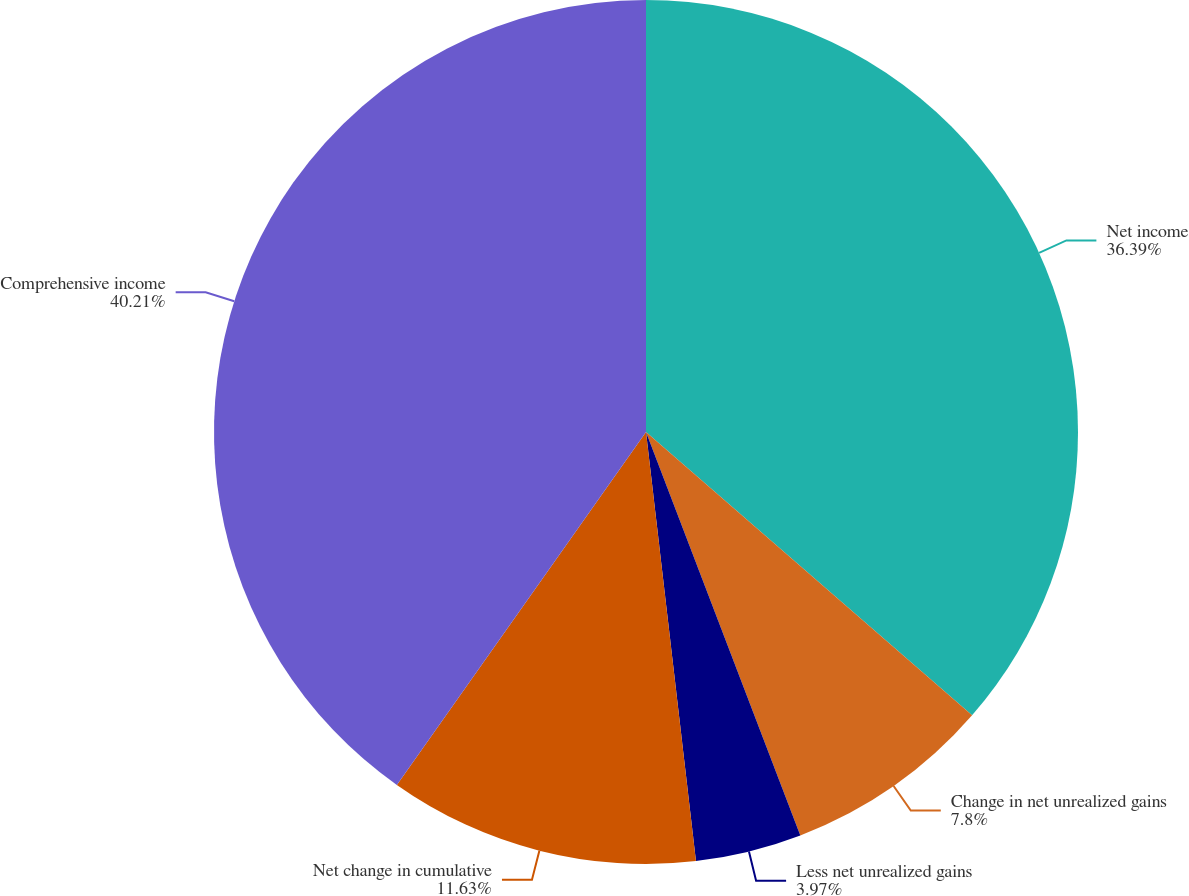Convert chart to OTSL. <chart><loc_0><loc_0><loc_500><loc_500><pie_chart><fcel>Net income<fcel>Change in net unrealized gains<fcel>Less net unrealized gains<fcel>Net change in cumulative<fcel>Comprehensive income<nl><fcel>36.39%<fcel>7.8%<fcel>3.97%<fcel>11.63%<fcel>40.22%<nl></chart> 